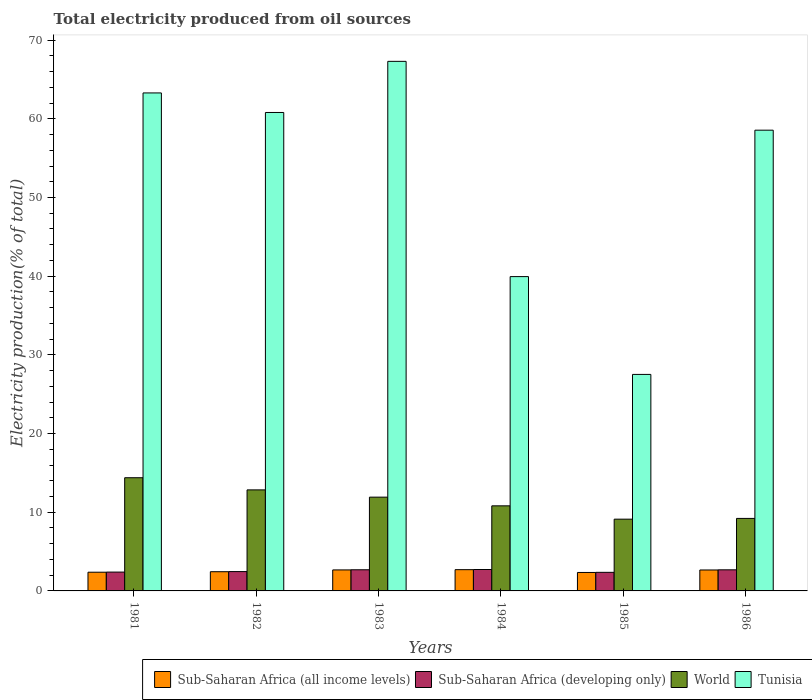How many different coloured bars are there?
Your answer should be very brief. 4. How many bars are there on the 2nd tick from the left?
Offer a terse response. 4. How many bars are there on the 1st tick from the right?
Your answer should be compact. 4. What is the label of the 1st group of bars from the left?
Make the answer very short. 1981. What is the total electricity produced in Tunisia in 1986?
Ensure brevity in your answer.  58.56. Across all years, what is the maximum total electricity produced in Sub-Saharan Africa (developing only)?
Ensure brevity in your answer.  2.72. Across all years, what is the minimum total electricity produced in Sub-Saharan Africa (all income levels)?
Make the answer very short. 2.35. What is the total total electricity produced in Sub-Saharan Africa (all income levels) in the graph?
Provide a short and direct response. 15.2. What is the difference between the total electricity produced in World in 1982 and that in 1984?
Your answer should be compact. 2.03. What is the difference between the total electricity produced in Tunisia in 1986 and the total electricity produced in Sub-Saharan Africa (all income levels) in 1985?
Provide a short and direct response. 56.21. What is the average total electricity produced in Tunisia per year?
Make the answer very short. 52.9. In the year 1982, what is the difference between the total electricity produced in World and total electricity produced in Sub-Saharan Africa (developing only)?
Provide a short and direct response. 10.38. What is the ratio of the total electricity produced in Sub-Saharan Africa (all income levels) in 1982 to that in 1986?
Your response must be concise. 0.92. Is the total electricity produced in Tunisia in 1982 less than that in 1985?
Provide a succinct answer. No. Is the difference between the total electricity produced in World in 1983 and 1984 greater than the difference between the total electricity produced in Sub-Saharan Africa (developing only) in 1983 and 1984?
Your answer should be very brief. Yes. What is the difference between the highest and the second highest total electricity produced in Tunisia?
Provide a succinct answer. 4.01. What is the difference between the highest and the lowest total electricity produced in Sub-Saharan Africa (developing only)?
Your answer should be compact. 0.36. In how many years, is the total electricity produced in Sub-Saharan Africa (all income levels) greater than the average total electricity produced in Sub-Saharan Africa (all income levels) taken over all years?
Offer a terse response. 3. Is the sum of the total electricity produced in World in 1981 and 1982 greater than the maximum total electricity produced in Tunisia across all years?
Give a very brief answer. No. What does the 2nd bar from the left in 1984 represents?
Offer a very short reply. Sub-Saharan Africa (developing only). Is it the case that in every year, the sum of the total electricity produced in Sub-Saharan Africa (developing only) and total electricity produced in World is greater than the total electricity produced in Sub-Saharan Africa (all income levels)?
Your answer should be compact. Yes. What is the difference between two consecutive major ticks on the Y-axis?
Offer a terse response. 10. Are the values on the major ticks of Y-axis written in scientific E-notation?
Your answer should be very brief. No. Does the graph contain grids?
Make the answer very short. No. How many legend labels are there?
Provide a short and direct response. 4. What is the title of the graph?
Your response must be concise. Total electricity produced from oil sources. What is the label or title of the X-axis?
Offer a very short reply. Years. What is the Electricity production(% of total) in Sub-Saharan Africa (all income levels) in 1981?
Offer a terse response. 2.38. What is the Electricity production(% of total) of Sub-Saharan Africa (developing only) in 1981?
Ensure brevity in your answer.  2.39. What is the Electricity production(% of total) of World in 1981?
Keep it short and to the point. 14.39. What is the Electricity production(% of total) in Tunisia in 1981?
Ensure brevity in your answer.  63.29. What is the Electricity production(% of total) of Sub-Saharan Africa (all income levels) in 1982?
Offer a terse response. 2.44. What is the Electricity production(% of total) in Sub-Saharan Africa (developing only) in 1982?
Your response must be concise. 2.46. What is the Electricity production(% of total) of World in 1982?
Make the answer very short. 12.84. What is the Electricity production(% of total) of Tunisia in 1982?
Give a very brief answer. 60.81. What is the Electricity production(% of total) of Sub-Saharan Africa (all income levels) in 1983?
Your answer should be compact. 2.67. What is the Electricity production(% of total) of Sub-Saharan Africa (developing only) in 1983?
Provide a short and direct response. 2.69. What is the Electricity production(% of total) in World in 1983?
Provide a short and direct response. 11.92. What is the Electricity production(% of total) in Tunisia in 1983?
Your response must be concise. 67.3. What is the Electricity production(% of total) of Sub-Saharan Africa (all income levels) in 1984?
Provide a succinct answer. 2.7. What is the Electricity production(% of total) of Sub-Saharan Africa (developing only) in 1984?
Provide a short and direct response. 2.72. What is the Electricity production(% of total) of World in 1984?
Keep it short and to the point. 10.81. What is the Electricity production(% of total) in Tunisia in 1984?
Your answer should be compact. 39.95. What is the Electricity production(% of total) in Sub-Saharan Africa (all income levels) in 1985?
Ensure brevity in your answer.  2.35. What is the Electricity production(% of total) in Sub-Saharan Africa (developing only) in 1985?
Your answer should be very brief. 2.36. What is the Electricity production(% of total) in World in 1985?
Keep it short and to the point. 9.12. What is the Electricity production(% of total) in Tunisia in 1985?
Keep it short and to the point. 27.52. What is the Electricity production(% of total) of Sub-Saharan Africa (all income levels) in 1986?
Ensure brevity in your answer.  2.66. What is the Electricity production(% of total) in Sub-Saharan Africa (developing only) in 1986?
Provide a succinct answer. 2.68. What is the Electricity production(% of total) in World in 1986?
Keep it short and to the point. 9.21. What is the Electricity production(% of total) of Tunisia in 1986?
Offer a terse response. 58.56. Across all years, what is the maximum Electricity production(% of total) of Sub-Saharan Africa (all income levels)?
Offer a terse response. 2.7. Across all years, what is the maximum Electricity production(% of total) of Sub-Saharan Africa (developing only)?
Make the answer very short. 2.72. Across all years, what is the maximum Electricity production(% of total) in World?
Ensure brevity in your answer.  14.39. Across all years, what is the maximum Electricity production(% of total) of Tunisia?
Your response must be concise. 67.3. Across all years, what is the minimum Electricity production(% of total) of Sub-Saharan Africa (all income levels)?
Offer a terse response. 2.35. Across all years, what is the minimum Electricity production(% of total) in Sub-Saharan Africa (developing only)?
Keep it short and to the point. 2.36. Across all years, what is the minimum Electricity production(% of total) in World?
Your response must be concise. 9.12. Across all years, what is the minimum Electricity production(% of total) of Tunisia?
Keep it short and to the point. 27.52. What is the total Electricity production(% of total) in Sub-Saharan Africa (all income levels) in the graph?
Ensure brevity in your answer.  15.2. What is the total Electricity production(% of total) in Sub-Saharan Africa (developing only) in the graph?
Offer a terse response. 15.31. What is the total Electricity production(% of total) of World in the graph?
Make the answer very short. 68.29. What is the total Electricity production(% of total) in Tunisia in the graph?
Your answer should be very brief. 317.43. What is the difference between the Electricity production(% of total) in Sub-Saharan Africa (all income levels) in 1981 and that in 1982?
Your answer should be very brief. -0.06. What is the difference between the Electricity production(% of total) in Sub-Saharan Africa (developing only) in 1981 and that in 1982?
Ensure brevity in your answer.  -0.06. What is the difference between the Electricity production(% of total) in World in 1981 and that in 1982?
Provide a short and direct response. 1.55. What is the difference between the Electricity production(% of total) of Tunisia in 1981 and that in 1982?
Offer a terse response. 2.48. What is the difference between the Electricity production(% of total) in Sub-Saharan Africa (all income levels) in 1981 and that in 1983?
Provide a short and direct response. -0.29. What is the difference between the Electricity production(% of total) in Sub-Saharan Africa (developing only) in 1981 and that in 1983?
Give a very brief answer. -0.29. What is the difference between the Electricity production(% of total) of World in 1981 and that in 1983?
Your response must be concise. 2.47. What is the difference between the Electricity production(% of total) of Tunisia in 1981 and that in 1983?
Offer a very short reply. -4.01. What is the difference between the Electricity production(% of total) of Sub-Saharan Africa (all income levels) in 1981 and that in 1984?
Ensure brevity in your answer.  -0.33. What is the difference between the Electricity production(% of total) of Sub-Saharan Africa (developing only) in 1981 and that in 1984?
Your response must be concise. -0.33. What is the difference between the Electricity production(% of total) of World in 1981 and that in 1984?
Provide a short and direct response. 3.57. What is the difference between the Electricity production(% of total) in Tunisia in 1981 and that in 1984?
Make the answer very short. 23.34. What is the difference between the Electricity production(% of total) of Sub-Saharan Africa (all income levels) in 1981 and that in 1985?
Make the answer very short. 0.03. What is the difference between the Electricity production(% of total) of Sub-Saharan Africa (developing only) in 1981 and that in 1985?
Provide a short and direct response. 0.03. What is the difference between the Electricity production(% of total) of World in 1981 and that in 1985?
Give a very brief answer. 5.27. What is the difference between the Electricity production(% of total) in Tunisia in 1981 and that in 1985?
Provide a succinct answer. 35.78. What is the difference between the Electricity production(% of total) in Sub-Saharan Africa (all income levels) in 1981 and that in 1986?
Ensure brevity in your answer.  -0.28. What is the difference between the Electricity production(% of total) of Sub-Saharan Africa (developing only) in 1981 and that in 1986?
Your answer should be very brief. -0.29. What is the difference between the Electricity production(% of total) in World in 1981 and that in 1986?
Your answer should be compact. 5.17. What is the difference between the Electricity production(% of total) in Tunisia in 1981 and that in 1986?
Provide a short and direct response. 4.73. What is the difference between the Electricity production(% of total) of Sub-Saharan Africa (all income levels) in 1982 and that in 1983?
Give a very brief answer. -0.23. What is the difference between the Electricity production(% of total) of Sub-Saharan Africa (developing only) in 1982 and that in 1983?
Make the answer very short. -0.23. What is the difference between the Electricity production(% of total) in World in 1982 and that in 1983?
Provide a succinct answer. 0.92. What is the difference between the Electricity production(% of total) of Tunisia in 1982 and that in 1983?
Your answer should be compact. -6.5. What is the difference between the Electricity production(% of total) of Sub-Saharan Africa (all income levels) in 1982 and that in 1984?
Provide a short and direct response. -0.26. What is the difference between the Electricity production(% of total) of Sub-Saharan Africa (developing only) in 1982 and that in 1984?
Make the answer very short. -0.26. What is the difference between the Electricity production(% of total) of World in 1982 and that in 1984?
Your answer should be compact. 2.03. What is the difference between the Electricity production(% of total) in Tunisia in 1982 and that in 1984?
Give a very brief answer. 20.86. What is the difference between the Electricity production(% of total) of Sub-Saharan Africa (all income levels) in 1982 and that in 1985?
Make the answer very short. 0.1. What is the difference between the Electricity production(% of total) in Sub-Saharan Africa (developing only) in 1982 and that in 1985?
Ensure brevity in your answer.  0.1. What is the difference between the Electricity production(% of total) in World in 1982 and that in 1985?
Give a very brief answer. 3.72. What is the difference between the Electricity production(% of total) in Tunisia in 1982 and that in 1985?
Your response must be concise. 33.29. What is the difference between the Electricity production(% of total) in Sub-Saharan Africa (all income levels) in 1982 and that in 1986?
Your response must be concise. -0.22. What is the difference between the Electricity production(% of total) of Sub-Saharan Africa (developing only) in 1982 and that in 1986?
Give a very brief answer. -0.22. What is the difference between the Electricity production(% of total) in World in 1982 and that in 1986?
Offer a terse response. 3.63. What is the difference between the Electricity production(% of total) in Tunisia in 1982 and that in 1986?
Offer a terse response. 2.25. What is the difference between the Electricity production(% of total) of Sub-Saharan Africa (all income levels) in 1983 and that in 1984?
Keep it short and to the point. -0.03. What is the difference between the Electricity production(% of total) of Sub-Saharan Africa (developing only) in 1983 and that in 1984?
Your answer should be very brief. -0.03. What is the difference between the Electricity production(% of total) of World in 1983 and that in 1984?
Ensure brevity in your answer.  1.1. What is the difference between the Electricity production(% of total) of Tunisia in 1983 and that in 1984?
Give a very brief answer. 27.36. What is the difference between the Electricity production(% of total) of Sub-Saharan Africa (all income levels) in 1983 and that in 1985?
Your answer should be very brief. 0.32. What is the difference between the Electricity production(% of total) of Sub-Saharan Africa (developing only) in 1983 and that in 1985?
Offer a very short reply. 0.33. What is the difference between the Electricity production(% of total) of World in 1983 and that in 1985?
Keep it short and to the point. 2.8. What is the difference between the Electricity production(% of total) in Tunisia in 1983 and that in 1985?
Keep it short and to the point. 39.79. What is the difference between the Electricity production(% of total) of Sub-Saharan Africa (all income levels) in 1983 and that in 1986?
Ensure brevity in your answer.  0.01. What is the difference between the Electricity production(% of total) of Sub-Saharan Africa (developing only) in 1983 and that in 1986?
Ensure brevity in your answer.  0.01. What is the difference between the Electricity production(% of total) of World in 1983 and that in 1986?
Give a very brief answer. 2.7. What is the difference between the Electricity production(% of total) of Tunisia in 1983 and that in 1986?
Give a very brief answer. 8.75. What is the difference between the Electricity production(% of total) of Sub-Saharan Africa (all income levels) in 1984 and that in 1985?
Your response must be concise. 0.36. What is the difference between the Electricity production(% of total) of Sub-Saharan Africa (developing only) in 1984 and that in 1985?
Offer a terse response. 0.36. What is the difference between the Electricity production(% of total) in World in 1984 and that in 1985?
Your answer should be compact. 1.69. What is the difference between the Electricity production(% of total) of Tunisia in 1984 and that in 1985?
Offer a terse response. 12.43. What is the difference between the Electricity production(% of total) of Sub-Saharan Africa (all income levels) in 1984 and that in 1986?
Your answer should be compact. 0.04. What is the difference between the Electricity production(% of total) in Sub-Saharan Africa (developing only) in 1984 and that in 1986?
Offer a very short reply. 0.04. What is the difference between the Electricity production(% of total) of World in 1984 and that in 1986?
Provide a short and direct response. 1.6. What is the difference between the Electricity production(% of total) of Tunisia in 1984 and that in 1986?
Provide a short and direct response. -18.61. What is the difference between the Electricity production(% of total) in Sub-Saharan Africa (all income levels) in 1985 and that in 1986?
Your answer should be very brief. -0.32. What is the difference between the Electricity production(% of total) of Sub-Saharan Africa (developing only) in 1985 and that in 1986?
Offer a very short reply. -0.32. What is the difference between the Electricity production(% of total) in World in 1985 and that in 1986?
Your answer should be very brief. -0.09. What is the difference between the Electricity production(% of total) in Tunisia in 1985 and that in 1986?
Your answer should be very brief. -31.04. What is the difference between the Electricity production(% of total) in Sub-Saharan Africa (all income levels) in 1981 and the Electricity production(% of total) in Sub-Saharan Africa (developing only) in 1982?
Your answer should be compact. -0.08. What is the difference between the Electricity production(% of total) of Sub-Saharan Africa (all income levels) in 1981 and the Electricity production(% of total) of World in 1982?
Keep it short and to the point. -10.46. What is the difference between the Electricity production(% of total) in Sub-Saharan Africa (all income levels) in 1981 and the Electricity production(% of total) in Tunisia in 1982?
Ensure brevity in your answer.  -58.43. What is the difference between the Electricity production(% of total) in Sub-Saharan Africa (developing only) in 1981 and the Electricity production(% of total) in World in 1982?
Ensure brevity in your answer.  -10.45. What is the difference between the Electricity production(% of total) of Sub-Saharan Africa (developing only) in 1981 and the Electricity production(% of total) of Tunisia in 1982?
Keep it short and to the point. -58.41. What is the difference between the Electricity production(% of total) of World in 1981 and the Electricity production(% of total) of Tunisia in 1982?
Give a very brief answer. -46.42. What is the difference between the Electricity production(% of total) of Sub-Saharan Africa (all income levels) in 1981 and the Electricity production(% of total) of Sub-Saharan Africa (developing only) in 1983?
Offer a very short reply. -0.31. What is the difference between the Electricity production(% of total) in Sub-Saharan Africa (all income levels) in 1981 and the Electricity production(% of total) in World in 1983?
Give a very brief answer. -9.54. What is the difference between the Electricity production(% of total) of Sub-Saharan Africa (all income levels) in 1981 and the Electricity production(% of total) of Tunisia in 1983?
Keep it short and to the point. -64.93. What is the difference between the Electricity production(% of total) of Sub-Saharan Africa (developing only) in 1981 and the Electricity production(% of total) of World in 1983?
Provide a succinct answer. -9.52. What is the difference between the Electricity production(% of total) in Sub-Saharan Africa (developing only) in 1981 and the Electricity production(% of total) in Tunisia in 1983?
Keep it short and to the point. -64.91. What is the difference between the Electricity production(% of total) in World in 1981 and the Electricity production(% of total) in Tunisia in 1983?
Make the answer very short. -52.92. What is the difference between the Electricity production(% of total) in Sub-Saharan Africa (all income levels) in 1981 and the Electricity production(% of total) in Sub-Saharan Africa (developing only) in 1984?
Your answer should be very brief. -0.34. What is the difference between the Electricity production(% of total) in Sub-Saharan Africa (all income levels) in 1981 and the Electricity production(% of total) in World in 1984?
Give a very brief answer. -8.44. What is the difference between the Electricity production(% of total) of Sub-Saharan Africa (all income levels) in 1981 and the Electricity production(% of total) of Tunisia in 1984?
Provide a succinct answer. -37.57. What is the difference between the Electricity production(% of total) in Sub-Saharan Africa (developing only) in 1981 and the Electricity production(% of total) in World in 1984?
Offer a very short reply. -8.42. What is the difference between the Electricity production(% of total) in Sub-Saharan Africa (developing only) in 1981 and the Electricity production(% of total) in Tunisia in 1984?
Your answer should be very brief. -37.55. What is the difference between the Electricity production(% of total) in World in 1981 and the Electricity production(% of total) in Tunisia in 1984?
Offer a very short reply. -25.56. What is the difference between the Electricity production(% of total) of Sub-Saharan Africa (all income levels) in 1981 and the Electricity production(% of total) of Sub-Saharan Africa (developing only) in 1985?
Give a very brief answer. 0.02. What is the difference between the Electricity production(% of total) in Sub-Saharan Africa (all income levels) in 1981 and the Electricity production(% of total) in World in 1985?
Your answer should be very brief. -6.74. What is the difference between the Electricity production(% of total) of Sub-Saharan Africa (all income levels) in 1981 and the Electricity production(% of total) of Tunisia in 1985?
Provide a succinct answer. -25.14. What is the difference between the Electricity production(% of total) in Sub-Saharan Africa (developing only) in 1981 and the Electricity production(% of total) in World in 1985?
Your answer should be compact. -6.73. What is the difference between the Electricity production(% of total) of Sub-Saharan Africa (developing only) in 1981 and the Electricity production(% of total) of Tunisia in 1985?
Make the answer very short. -25.12. What is the difference between the Electricity production(% of total) of World in 1981 and the Electricity production(% of total) of Tunisia in 1985?
Ensure brevity in your answer.  -13.13. What is the difference between the Electricity production(% of total) in Sub-Saharan Africa (all income levels) in 1981 and the Electricity production(% of total) in Sub-Saharan Africa (developing only) in 1986?
Your response must be concise. -0.3. What is the difference between the Electricity production(% of total) of Sub-Saharan Africa (all income levels) in 1981 and the Electricity production(% of total) of World in 1986?
Offer a terse response. -6.84. What is the difference between the Electricity production(% of total) of Sub-Saharan Africa (all income levels) in 1981 and the Electricity production(% of total) of Tunisia in 1986?
Ensure brevity in your answer.  -56.18. What is the difference between the Electricity production(% of total) of Sub-Saharan Africa (developing only) in 1981 and the Electricity production(% of total) of World in 1986?
Your answer should be compact. -6.82. What is the difference between the Electricity production(% of total) of Sub-Saharan Africa (developing only) in 1981 and the Electricity production(% of total) of Tunisia in 1986?
Give a very brief answer. -56.16. What is the difference between the Electricity production(% of total) of World in 1981 and the Electricity production(% of total) of Tunisia in 1986?
Your response must be concise. -44.17. What is the difference between the Electricity production(% of total) of Sub-Saharan Africa (all income levels) in 1982 and the Electricity production(% of total) of Sub-Saharan Africa (developing only) in 1983?
Offer a terse response. -0.25. What is the difference between the Electricity production(% of total) in Sub-Saharan Africa (all income levels) in 1982 and the Electricity production(% of total) in World in 1983?
Offer a terse response. -9.48. What is the difference between the Electricity production(% of total) of Sub-Saharan Africa (all income levels) in 1982 and the Electricity production(% of total) of Tunisia in 1983?
Give a very brief answer. -64.86. What is the difference between the Electricity production(% of total) in Sub-Saharan Africa (developing only) in 1982 and the Electricity production(% of total) in World in 1983?
Offer a very short reply. -9.46. What is the difference between the Electricity production(% of total) of Sub-Saharan Africa (developing only) in 1982 and the Electricity production(% of total) of Tunisia in 1983?
Your answer should be very brief. -64.85. What is the difference between the Electricity production(% of total) of World in 1982 and the Electricity production(% of total) of Tunisia in 1983?
Make the answer very short. -54.46. What is the difference between the Electricity production(% of total) of Sub-Saharan Africa (all income levels) in 1982 and the Electricity production(% of total) of Sub-Saharan Africa (developing only) in 1984?
Provide a succinct answer. -0.28. What is the difference between the Electricity production(% of total) in Sub-Saharan Africa (all income levels) in 1982 and the Electricity production(% of total) in World in 1984?
Provide a short and direct response. -8.37. What is the difference between the Electricity production(% of total) in Sub-Saharan Africa (all income levels) in 1982 and the Electricity production(% of total) in Tunisia in 1984?
Your response must be concise. -37.51. What is the difference between the Electricity production(% of total) of Sub-Saharan Africa (developing only) in 1982 and the Electricity production(% of total) of World in 1984?
Make the answer very short. -8.36. What is the difference between the Electricity production(% of total) in Sub-Saharan Africa (developing only) in 1982 and the Electricity production(% of total) in Tunisia in 1984?
Provide a succinct answer. -37.49. What is the difference between the Electricity production(% of total) in World in 1982 and the Electricity production(% of total) in Tunisia in 1984?
Make the answer very short. -27.11. What is the difference between the Electricity production(% of total) in Sub-Saharan Africa (all income levels) in 1982 and the Electricity production(% of total) in Sub-Saharan Africa (developing only) in 1985?
Offer a terse response. 0.08. What is the difference between the Electricity production(% of total) in Sub-Saharan Africa (all income levels) in 1982 and the Electricity production(% of total) in World in 1985?
Your answer should be compact. -6.68. What is the difference between the Electricity production(% of total) in Sub-Saharan Africa (all income levels) in 1982 and the Electricity production(% of total) in Tunisia in 1985?
Give a very brief answer. -25.07. What is the difference between the Electricity production(% of total) in Sub-Saharan Africa (developing only) in 1982 and the Electricity production(% of total) in World in 1985?
Keep it short and to the point. -6.66. What is the difference between the Electricity production(% of total) in Sub-Saharan Africa (developing only) in 1982 and the Electricity production(% of total) in Tunisia in 1985?
Provide a succinct answer. -25.06. What is the difference between the Electricity production(% of total) of World in 1982 and the Electricity production(% of total) of Tunisia in 1985?
Your answer should be very brief. -14.68. What is the difference between the Electricity production(% of total) of Sub-Saharan Africa (all income levels) in 1982 and the Electricity production(% of total) of Sub-Saharan Africa (developing only) in 1986?
Offer a terse response. -0.24. What is the difference between the Electricity production(% of total) of Sub-Saharan Africa (all income levels) in 1982 and the Electricity production(% of total) of World in 1986?
Provide a succinct answer. -6.77. What is the difference between the Electricity production(% of total) in Sub-Saharan Africa (all income levels) in 1982 and the Electricity production(% of total) in Tunisia in 1986?
Provide a short and direct response. -56.12. What is the difference between the Electricity production(% of total) of Sub-Saharan Africa (developing only) in 1982 and the Electricity production(% of total) of World in 1986?
Provide a succinct answer. -6.76. What is the difference between the Electricity production(% of total) of Sub-Saharan Africa (developing only) in 1982 and the Electricity production(% of total) of Tunisia in 1986?
Provide a short and direct response. -56.1. What is the difference between the Electricity production(% of total) of World in 1982 and the Electricity production(% of total) of Tunisia in 1986?
Your response must be concise. -45.72. What is the difference between the Electricity production(% of total) in Sub-Saharan Africa (all income levels) in 1983 and the Electricity production(% of total) in Sub-Saharan Africa (developing only) in 1984?
Your answer should be very brief. -0.05. What is the difference between the Electricity production(% of total) of Sub-Saharan Africa (all income levels) in 1983 and the Electricity production(% of total) of World in 1984?
Ensure brevity in your answer.  -8.14. What is the difference between the Electricity production(% of total) in Sub-Saharan Africa (all income levels) in 1983 and the Electricity production(% of total) in Tunisia in 1984?
Give a very brief answer. -37.28. What is the difference between the Electricity production(% of total) in Sub-Saharan Africa (developing only) in 1983 and the Electricity production(% of total) in World in 1984?
Provide a succinct answer. -8.13. What is the difference between the Electricity production(% of total) in Sub-Saharan Africa (developing only) in 1983 and the Electricity production(% of total) in Tunisia in 1984?
Provide a short and direct response. -37.26. What is the difference between the Electricity production(% of total) of World in 1983 and the Electricity production(% of total) of Tunisia in 1984?
Offer a terse response. -28.03. What is the difference between the Electricity production(% of total) of Sub-Saharan Africa (all income levels) in 1983 and the Electricity production(% of total) of Sub-Saharan Africa (developing only) in 1985?
Provide a succinct answer. 0.31. What is the difference between the Electricity production(% of total) in Sub-Saharan Africa (all income levels) in 1983 and the Electricity production(% of total) in World in 1985?
Give a very brief answer. -6.45. What is the difference between the Electricity production(% of total) in Sub-Saharan Africa (all income levels) in 1983 and the Electricity production(% of total) in Tunisia in 1985?
Give a very brief answer. -24.85. What is the difference between the Electricity production(% of total) in Sub-Saharan Africa (developing only) in 1983 and the Electricity production(% of total) in World in 1985?
Make the answer very short. -6.43. What is the difference between the Electricity production(% of total) of Sub-Saharan Africa (developing only) in 1983 and the Electricity production(% of total) of Tunisia in 1985?
Your answer should be compact. -24.83. What is the difference between the Electricity production(% of total) in World in 1983 and the Electricity production(% of total) in Tunisia in 1985?
Ensure brevity in your answer.  -15.6. What is the difference between the Electricity production(% of total) in Sub-Saharan Africa (all income levels) in 1983 and the Electricity production(% of total) in Sub-Saharan Africa (developing only) in 1986?
Make the answer very short. -0.01. What is the difference between the Electricity production(% of total) of Sub-Saharan Africa (all income levels) in 1983 and the Electricity production(% of total) of World in 1986?
Your response must be concise. -6.54. What is the difference between the Electricity production(% of total) of Sub-Saharan Africa (all income levels) in 1983 and the Electricity production(% of total) of Tunisia in 1986?
Your response must be concise. -55.89. What is the difference between the Electricity production(% of total) of Sub-Saharan Africa (developing only) in 1983 and the Electricity production(% of total) of World in 1986?
Give a very brief answer. -6.53. What is the difference between the Electricity production(% of total) of Sub-Saharan Africa (developing only) in 1983 and the Electricity production(% of total) of Tunisia in 1986?
Your answer should be very brief. -55.87. What is the difference between the Electricity production(% of total) of World in 1983 and the Electricity production(% of total) of Tunisia in 1986?
Give a very brief answer. -46.64. What is the difference between the Electricity production(% of total) in Sub-Saharan Africa (all income levels) in 1984 and the Electricity production(% of total) in Sub-Saharan Africa (developing only) in 1985?
Offer a very short reply. 0.34. What is the difference between the Electricity production(% of total) of Sub-Saharan Africa (all income levels) in 1984 and the Electricity production(% of total) of World in 1985?
Provide a succinct answer. -6.42. What is the difference between the Electricity production(% of total) of Sub-Saharan Africa (all income levels) in 1984 and the Electricity production(% of total) of Tunisia in 1985?
Offer a terse response. -24.81. What is the difference between the Electricity production(% of total) of Sub-Saharan Africa (developing only) in 1984 and the Electricity production(% of total) of World in 1985?
Offer a very short reply. -6.4. What is the difference between the Electricity production(% of total) of Sub-Saharan Africa (developing only) in 1984 and the Electricity production(% of total) of Tunisia in 1985?
Offer a terse response. -24.79. What is the difference between the Electricity production(% of total) of World in 1984 and the Electricity production(% of total) of Tunisia in 1985?
Provide a succinct answer. -16.7. What is the difference between the Electricity production(% of total) of Sub-Saharan Africa (all income levels) in 1984 and the Electricity production(% of total) of Sub-Saharan Africa (developing only) in 1986?
Provide a short and direct response. 0.02. What is the difference between the Electricity production(% of total) of Sub-Saharan Africa (all income levels) in 1984 and the Electricity production(% of total) of World in 1986?
Your answer should be very brief. -6.51. What is the difference between the Electricity production(% of total) of Sub-Saharan Africa (all income levels) in 1984 and the Electricity production(% of total) of Tunisia in 1986?
Make the answer very short. -55.86. What is the difference between the Electricity production(% of total) of Sub-Saharan Africa (developing only) in 1984 and the Electricity production(% of total) of World in 1986?
Provide a short and direct response. -6.49. What is the difference between the Electricity production(% of total) of Sub-Saharan Africa (developing only) in 1984 and the Electricity production(% of total) of Tunisia in 1986?
Offer a terse response. -55.84. What is the difference between the Electricity production(% of total) of World in 1984 and the Electricity production(% of total) of Tunisia in 1986?
Make the answer very short. -47.74. What is the difference between the Electricity production(% of total) in Sub-Saharan Africa (all income levels) in 1985 and the Electricity production(% of total) in Sub-Saharan Africa (developing only) in 1986?
Keep it short and to the point. -0.34. What is the difference between the Electricity production(% of total) of Sub-Saharan Africa (all income levels) in 1985 and the Electricity production(% of total) of World in 1986?
Ensure brevity in your answer.  -6.87. What is the difference between the Electricity production(% of total) of Sub-Saharan Africa (all income levels) in 1985 and the Electricity production(% of total) of Tunisia in 1986?
Ensure brevity in your answer.  -56.21. What is the difference between the Electricity production(% of total) in Sub-Saharan Africa (developing only) in 1985 and the Electricity production(% of total) in World in 1986?
Offer a very short reply. -6.85. What is the difference between the Electricity production(% of total) of Sub-Saharan Africa (developing only) in 1985 and the Electricity production(% of total) of Tunisia in 1986?
Give a very brief answer. -56.2. What is the difference between the Electricity production(% of total) in World in 1985 and the Electricity production(% of total) in Tunisia in 1986?
Provide a short and direct response. -49.44. What is the average Electricity production(% of total) in Sub-Saharan Africa (all income levels) per year?
Your response must be concise. 2.53. What is the average Electricity production(% of total) in Sub-Saharan Africa (developing only) per year?
Offer a terse response. 2.55. What is the average Electricity production(% of total) of World per year?
Ensure brevity in your answer.  11.38. What is the average Electricity production(% of total) of Tunisia per year?
Keep it short and to the point. 52.9. In the year 1981, what is the difference between the Electricity production(% of total) in Sub-Saharan Africa (all income levels) and Electricity production(% of total) in Sub-Saharan Africa (developing only)?
Provide a short and direct response. -0.02. In the year 1981, what is the difference between the Electricity production(% of total) in Sub-Saharan Africa (all income levels) and Electricity production(% of total) in World?
Keep it short and to the point. -12.01. In the year 1981, what is the difference between the Electricity production(% of total) in Sub-Saharan Africa (all income levels) and Electricity production(% of total) in Tunisia?
Your answer should be compact. -60.91. In the year 1981, what is the difference between the Electricity production(% of total) in Sub-Saharan Africa (developing only) and Electricity production(% of total) in World?
Offer a very short reply. -11.99. In the year 1981, what is the difference between the Electricity production(% of total) of Sub-Saharan Africa (developing only) and Electricity production(% of total) of Tunisia?
Make the answer very short. -60.9. In the year 1981, what is the difference between the Electricity production(% of total) of World and Electricity production(% of total) of Tunisia?
Your answer should be very brief. -48.9. In the year 1982, what is the difference between the Electricity production(% of total) in Sub-Saharan Africa (all income levels) and Electricity production(% of total) in Sub-Saharan Africa (developing only)?
Provide a succinct answer. -0.02. In the year 1982, what is the difference between the Electricity production(% of total) of Sub-Saharan Africa (all income levels) and Electricity production(% of total) of World?
Provide a succinct answer. -10.4. In the year 1982, what is the difference between the Electricity production(% of total) of Sub-Saharan Africa (all income levels) and Electricity production(% of total) of Tunisia?
Your answer should be compact. -58.37. In the year 1982, what is the difference between the Electricity production(% of total) of Sub-Saharan Africa (developing only) and Electricity production(% of total) of World?
Keep it short and to the point. -10.38. In the year 1982, what is the difference between the Electricity production(% of total) in Sub-Saharan Africa (developing only) and Electricity production(% of total) in Tunisia?
Offer a terse response. -58.35. In the year 1982, what is the difference between the Electricity production(% of total) of World and Electricity production(% of total) of Tunisia?
Keep it short and to the point. -47.97. In the year 1983, what is the difference between the Electricity production(% of total) of Sub-Saharan Africa (all income levels) and Electricity production(% of total) of Sub-Saharan Africa (developing only)?
Make the answer very short. -0.02. In the year 1983, what is the difference between the Electricity production(% of total) in Sub-Saharan Africa (all income levels) and Electricity production(% of total) in World?
Provide a short and direct response. -9.25. In the year 1983, what is the difference between the Electricity production(% of total) of Sub-Saharan Africa (all income levels) and Electricity production(% of total) of Tunisia?
Your answer should be very brief. -64.64. In the year 1983, what is the difference between the Electricity production(% of total) of Sub-Saharan Africa (developing only) and Electricity production(% of total) of World?
Give a very brief answer. -9.23. In the year 1983, what is the difference between the Electricity production(% of total) in Sub-Saharan Africa (developing only) and Electricity production(% of total) in Tunisia?
Your answer should be very brief. -64.62. In the year 1983, what is the difference between the Electricity production(% of total) of World and Electricity production(% of total) of Tunisia?
Ensure brevity in your answer.  -55.39. In the year 1984, what is the difference between the Electricity production(% of total) in Sub-Saharan Africa (all income levels) and Electricity production(% of total) in Sub-Saharan Africa (developing only)?
Your response must be concise. -0.02. In the year 1984, what is the difference between the Electricity production(% of total) of Sub-Saharan Africa (all income levels) and Electricity production(% of total) of World?
Ensure brevity in your answer.  -8.11. In the year 1984, what is the difference between the Electricity production(% of total) in Sub-Saharan Africa (all income levels) and Electricity production(% of total) in Tunisia?
Give a very brief answer. -37.25. In the year 1984, what is the difference between the Electricity production(% of total) in Sub-Saharan Africa (developing only) and Electricity production(% of total) in World?
Make the answer very short. -8.09. In the year 1984, what is the difference between the Electricity production(% of total) in Sub-Saharan Africa (developing only) and Electricity production(% of total) in Tunisia?
Offer a very short reply. -37.23. In the year 1984, what is the difference between the Electricity production(% of total) of World and Electricity production(% of total) of Tunisia?
Provide a succinct answer. -29.13. In the year 1985, what is the difference between the Electricity production(% of total) in Sub-Saharan Africa (all income levels) and Electricity production(% of total) in Sub-Saharan Africa (developing only)?
Make the answer very short. -0.02. In the year 1985, what is the difference between the Electricity production(% of total) of Sub-Saharan Africa (all income levels) and Electricity production(% of total) of World?
Your response must be concise. -6.78. In the year 1985, what is the difference between the Electricity production(% of total) of Sub-Saharan Africa (all income levels) and Electricity production(% of total) of Tunisia?
Make the answer very short. -25.17. In the year 1985, what is the difference between the Electricity production(% of total) in Sub-Saharan Africa (developing only) and Electricity production(% of total) in World?
Give a very brief answer. -6.76. In the year 1985, what is the difference between the Electricity production(% of total) in Sub-Saharan Africa (developing only) and Electricity production(% of total) in Tunisia?
Provide a short and direct response. -25.15. In the year 1985, what is the difference between the Electricity production(% of total) in World and Electricity production(% of total) in Tunisia?
Your answer should be very brief. -18.4. In the year 1986, what is the difference between the Electricity production(% of total) of Sub-Saharan Africa (all income levels) and Electricity production(% of total) of Sub-Saharan Africa (developing only)?
Offer a very short reply. -0.02. In the year 1986, what is the difference between the Electricity production(% of total) of Sub-Saharan Africa (all income levels) and Electricity production(% of total) of World?
Give a very brief answer. -6.55. In the year 1986, what is the difference between the Electricity production(% of total) of Sub-Saharan Africa (all income levels) and Electricity production(% of total) of Tunisia?
Keep it short and to the point. -55.9. In the year 1986, what is the difference between the Electricity production(% of total) of Sub-Saharan Africa (developing only) and Electricity production(% of total) of World?
Make the answer very short. -6.53. In the year 1986, what is the difference between the Electricity production(% of total) of Sub-Saharan Africa (developing only) and Electricity production(% of total) of Tunisia?
Give a very brief answer. -55.88. In the year 1986, what is the difference between the Electricity production(% of total) in World and Electricity production(% of total) in Tunisia?
Make the answer very short. -49.34. What is the ratio of the Electricity production(% of total) in Sub-Saharan Africa (all income levels) in 1981 to that in 1982?
Provide a short and direct response. 0.97. What is the ratio of the Electricity production(% of total) of Sub-Saharan Africa (developing only) in 1981 to that in 1982?
Your answer should be very brief. 0.97. What is the ratio of the Electricity production(% of total) in World in 1981 to that in 1982?
Keep it short and to the point. 1.12. What is the ratio of the Electricity production(% of total) of Tunisia in 1981 to that in 1982?
Give a very brief answer. 1.04. What is the ratio of the Electricity production(% of total) of Sub-Saharan Africa (all income levels) in 1981 to that in 1983?
Provide a succinct answer. 0.89. What is the ratio of the Electricity production(% of total) of Sub-Saharan Africa (developing only) in 1981 to that in 1983?
Give a very brief answer. 0.89. What is the ratio of the Electricity production(% of total) of World in 1981 to that in 1983?
Your response must be concise. 1.21. What is the ratio of the Electricity production(% of total) of Tunisia in 1981 to that in 1983?
Make the answer very short. 0.94. What is the ratio of the Electricity production(% of total) in Sub-Saharan Africa (all income levels) in 1981 to that in 1984?
Offer a very short reply. 0.88. What is the ratio of the Electricity production(% of total) in Sub-Saharan Africa (developing only) in 1981 to that in 1984?
Give a very brief answer. 0.88. What is the ratio of the Electricity production(% of total) in World in 1981 to that in 1984?
Keep it short and to the point. 1.33. What is the ratio of the Electricity production(% of total) in Tunisia in 1981 to that in 1984?
Your answer should be very brief. 1.58. What is the ratio of the Electricity production(% of total) in Sub-Saharan Africa (all income levels) in 1981 to that in 1985?
Your answer should be very brief. 1.01. What is the ratio of the Electricity production(% of total) of Sub-Saharan Africa (developing only) in 1981 to that in 1985?
Your answer should be compact. 1.01. What is the ratio of the Electricity production(% of total) in World in 1981 to that in 1985?
Provide a succinct answer. 1.58. What is the ratio of the Electricity production(% of total) in Tunisia in 1981 to that in 1985?
Keep it short and to the point. 2.3. What is the ratio of the Electricity production(% of total) of Sub-Saharan Africa (all income levels) in 1981 to that in 1986?
Your response must be concise. 0.89. What is the ratio of the Electricity production(% of total) of Sub-Saharan Africa (developing only) in 1981 to that in 1986?
Give a very brief answer. 0.89. What is the ratio of the Electricity production(% of total) of World in 1981 to that in 1986?
Provide a short and direct response. 1.56. What is the ratio of the Electricity production(% of total) of Tunisia in 1981 to that in 1986?
Make the answer very short. 1.08. What is the ratio of the Electricity production(% of total) of Sub-Saharan Africa (all income levels) in 1982 to that in 1983?
Provide a succinct answer. 0.91. What is the ratio of the Electricity production(% of total) of Sub-Saharan Africa (developing only) in 1982 to that in 1983?
Your response must be concise. 0.91. What is the ratio of the Electricity production(% of total) of World in 1982 to that in 1983?
Ensure brevity in your answer.  1.08. What is the ratio of the Electricity production(% of total) of Tunisia in 1982 to that in 1983?
Provide a succinct answer. 0.9. What is the ratio of the Electricity production(% of total) of Sub-Saharan Africa (all income levels) in 1982 to that in 1984?
Keep it short and to the point. 0.9. What is the ratio of the Electricity production(% of total) in Sub-Saharan Africa (developing only) in 1982 to that in 1984?
Ensure brevity in your answer.  0.9. What is the ratio of the Electricity production(% of total) in World in 1982 to that in 1984?
Your answer should be compact. 1.19. What is the ratio of the Electricity production(% of total) of Tunisia in 1982 to that in 1984?
Offer a very short reply. 1.52. What is the ratio of the Electricity production(% of total) in Sub-Saharan Africa (all income levels) in 1982 to that in 1985?
Offer a terse response. 1.04. What is the ratio of the Electricity production(% of total) of Sub-Saharan Africa (developing only) in 1982 to that in 1985?
Your response must be concise. 1.04. What is the ratio of the Electricity production(% of total) in World in 1982 to that in 1985?
Offer a very short reply. 1.41. What is the ratio of the Electricity production(% of total) in Tunisia in 1982 to that in 1985?
Your answer should be very brief. 2.21. What is the ratio of the Electricity production(% of total) of Sub-Saharan Africa (all income levels) in 1982 to that in 1986?
Your response must be concise. 0.92. What is the ratio of the Electricity production(% of total) of Sub-Saharan Africa (developing only) in 1982 to that in 1986?
Ensure brevity in your answer.  0.92. What is the ratio of the Electricity production(% of total) in World in 1982 to that in 1986?
Ensure brevity in your answer.  1.39. What is the ratio of the Electricity production(% of total) of Tunisia in 1982 to that in 1986?
Your answer should be compact. 1.04. What is the ratio of the Electricity production(% of total) of World in 1983 to that in 1984?
Ensure brevity in your answer.  1.1. What is the ratio of the Electricity production(% of total) in Tunisia in 1983 to that in 1984?
Keep it short and to the point. 1.68. What is the ratio of the Electricity production(% of total) in Sub-Saharan Africa (all income levels) in 1983 to that in 1985?
Your answer should be very brief. 1.14. What is the ratio of the Electricity production(% of total) of Sub-Saharan Africa (developing only) in 1983 to that in 1985?
Make the answer very short. 1.14. What is the ratio of the Electricity production(% of total) in World in 1983 to that in 1985?
Your answer should be compact. 1.31. What is the ratio of the Electricity production(% of total) in Tunisia in 1983 to that in 1985?
Your response must be concise. 2.45. What is the ratio of the Electricity production(% of total) of Sub-Saharan Africa (all income levels) in 1983 to that in 1986?
Provide a succinct answer. 1. What is the ratio of the Electricity production(% of total) in World in 1983 to that in 1986?
Provide a short and direct response. 1.29. What is the ratio of the Electricity production(% of total) of Tunisia in 1983 to that in 1986?
Offer a very short reply. 1.15. What is the ratio of the Electricity production(% of total) of Sub-Saharan Africa (all income levels) in 1984 to that in 1985?
Your answer should be compact. 1.15. What is the ratio of the Electricity production(% of total) in Sub-Saharan Africa (developing only) in 1984 to that in 1985?
Provide a short and direct response. 1.15. What is the ratio of the Electricity production(% of total) in World in 1984 to that in 1985?
Ensure brevity in your answer.  1.19. What is the ratio of the Electricity production(% of total) in Tunisia in 1984 to that in 1985?
Your answer should be very brief. 1.45. What is the ratio of the Electricity production(% of total) in Sub-Saharan Africa (all income levels) in 1984 to that in 1986?
Your response must be concise. 1.02. What is the ratio of the Electricity production(% of total) of Sub-Saharan Africa (developing only) in 1984 to that in 1986?
Give a very brief answer. 1.02. What is the ratio of the Electricity production(% of total) of World in 1984 to that in 1986?
Your answer should be compact. 1.17. What is the ratio of the Electricity production(% of total) in Tunisia in 1984 to that in 1986?
Offer a very short reply. 0.68. What is the ratio of the Electricity production(% of total) of Sub-Saharan Africa (all income levels) in 1985 to that in 1986?
Provide a short and direct response. 0.88. What is the ratio of the Electricity production(% of total) of Sub-Saharan Africa (developing only) in 1985 to that in 1986?
Ensure brevity in your answer.  0.88. What is the ratio of the Electricity production(% of total) of World in 1985 to that in 1986?
Your answer should be compact. 0.99. What is the ratio of the Electricity production(% of total) of Tunisia in 1985 to that in 1986?
Your response must be concise. 0.47. What is the difference between the highest and the second highest Electricity production(% of total) in Sub-Saharan Africa (all income levels)?
Give a very brief answer. 0.03. What is the difference between the highest and the second highest Electricity production(% of total) of Sub-Saharan Africa (developing only)?
Your answer should be compact. 0.03. What is the difference between the highest and the second highest Electricity production(% of total) in World?
Provide a succinct answer. 1.55. What is the difference between the highest and the second highest Electricity production(% of total) of Tunisia?
Provide a short and direct response. 4.01. What is the difference between the highest and the lowest Electricity production(% of total) in Sub-Saharan Africa (all income levels)?
Your response must be concise. 0.36. What is the difference between the highest and the lowest Electricity production(% of total) in Sub-Saharan Africa (developing only)?
Your answer should be compact. 0.36. What is the difference between the highest and the lowest Electricity production(% of total) in World?
Keep it short and to the point. 5.27. What is the difference between the highest and the lowest Electricity production(% of total) in Tunisia?
Keep it short and to the point. 39.79. 